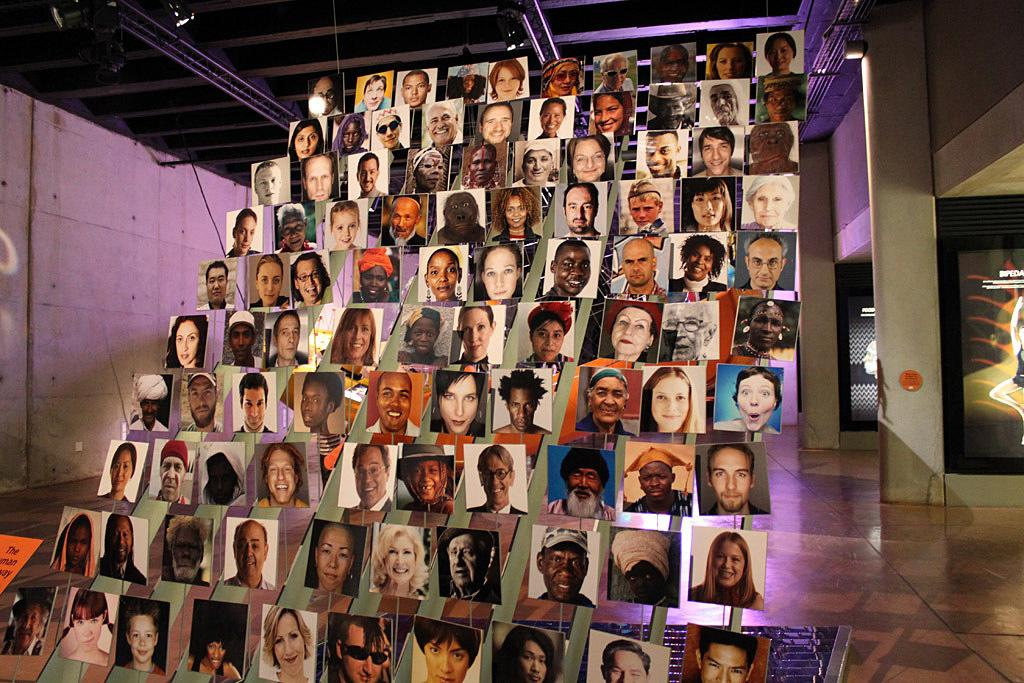What can be seen in the image? There are photos of people in the image. What is visible in the background of the image? There is a wall in the background of the image. Are there any objects attached to the wall in the background? Yes, there are objects attached to the wall in the background. What type of snakes can be seen slithering on the wall in the image? There are no snakes present in the image; it only features photos of people and objects attached to the wall. 